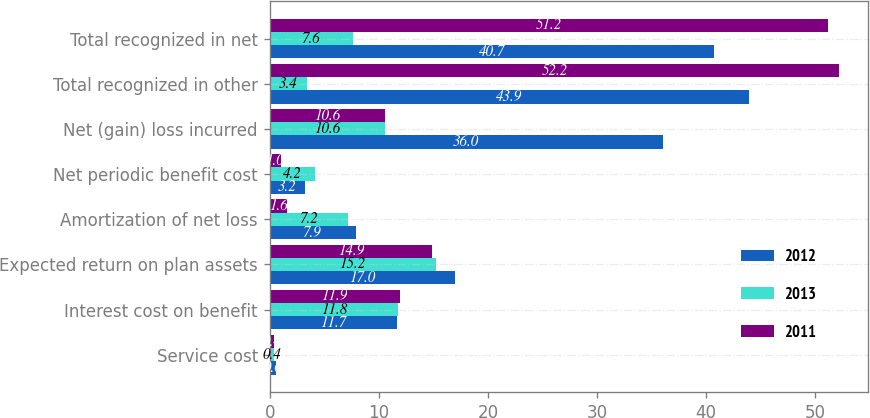Convert chart to OTSL. <chart><loc_0><loc_0><loc_500><loc_500><stacked_bar_chart><ecel><fcel>Service cost<fcel>Interest cost on benefit<fcel>Expected return on plan assets<fcel>Amortization of net loss<fcel>Net periodic benefit cost<fcel>Net (gain) loss incurred<fcel>Total recognized in other<fcel>Total recognized in net<nl><fcel>2012<fcel>0.6<fcel>11.7<fcel>17<fcel>7.9<fcel>3.2<fcel>36<fcel>43.9<fcel>40.7<nl><fcel>2013<fcel>0.4<fcel>11.8<fcel>15.2<fcel>7.2<fcel>4.2<fcel>10.6<fcel>3.4<fcel>7.6<nl><fcel>2011<fcel>0.4<fcel>11.9<fcel>14.9<fcel>1.6<fcel>1<fcel>10.6<fcel>52.2<fcel>51.2<nl></chart> 